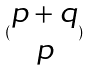<formula> <loc_0><loc_0><loc_500><loc_500>( \begin{matrix} p + q \\ p \end{matrix} )</formula> 